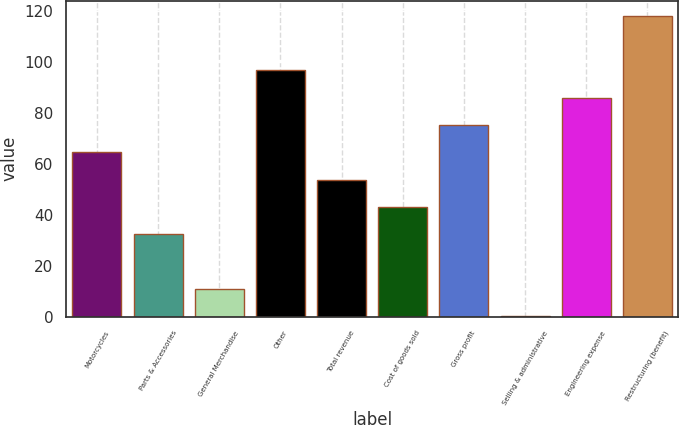<chart> <loc_0><loc_0><loc_500><loc_500><bar_chart><fcel>Motorcycles<fcel>Parts & Accessories<fcel>General Merchandise<fcel>Other<fcel>Total revenue<fcel>Cost of goods sold<fcel>Gross profit<fcel>Selling & administrative<fcel>Engineering expense<fcel>Restructuring (benefit)<nl><fcel>64.54<fcel>32.32<fcel>10.84<fcel>96.76<fcel>53.8<fcel>43.06<fcel>75.28<fcel>0.1<fcel>86.02<fcel>118.24<nl></chart> 